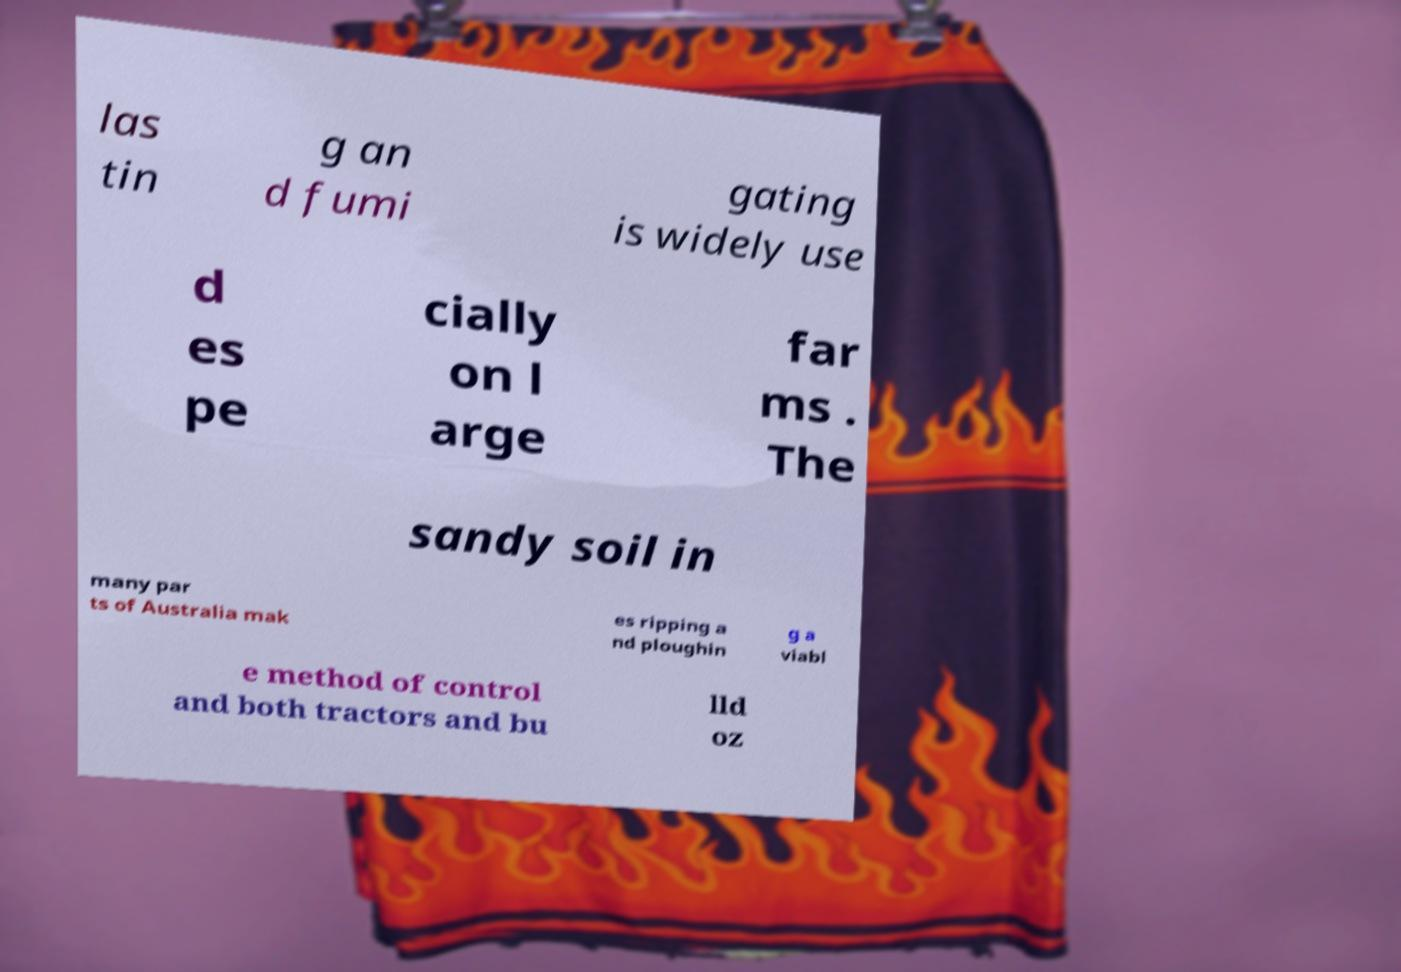Please identify and transcribe the text found in this image. las tin g an d fumi gating is widely use d es pe cially on l arge far ms . The sandy soil in many par ts of Australia mak es ripping a nd ploughin g a viabl e method of control and both tractors and bu lld oz 